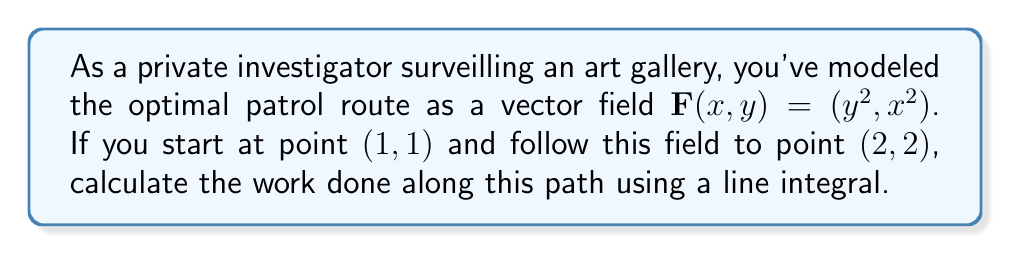Could you help me with this problem? To solve this problem, we'll follow these steps:

1) The line integral for work done is given by:
   $$\int_C \mathbf{F} \cdot d\mathbf{r}$$

2) We need to parameterize the path from $(1,1)$ to $(2,2)$. A simple parameterization is:
   $$x = 1 + t, y = 1 + t, \text{ where } 0 \leq t \leq 1$$

3) Now we can express $d\mathbf{r}$:
   $$d\mathbf{r} = \left(\frac{dx}{dt}, \frac{dy}{dt}\right)dt = (1,1)dt$$

4) Substituting the parameterization into $\mathbf{F}$:
   $$\mathbf{F}(t) = ((1+t)^2, (1+t)^2)$$

5) Now we can set up the integral:
   $$\int_0^1 ((1+t)^2, (1+t)^2) \cdot (1,1) dt$$

6) Simplifying:
   $$\int_0^1 2(1+t)^2 dt$$

7) Expanding:
   $$\int_0^1 2(1 + 2t + t^2) dt = \int_0^1 (2 + 4t + 2t^2) dt$$

8) Integrating:
   $$\left[2t + 2t^2 + \frac{2}{3}t^3\right]_0^1$$

9) Evaluating:
   $$(2 + 2 + \frac{2}{3}) - (0 + 0 + 0) = \frac{14}{3}$$
Answer: $\frac{14}{3}$ 